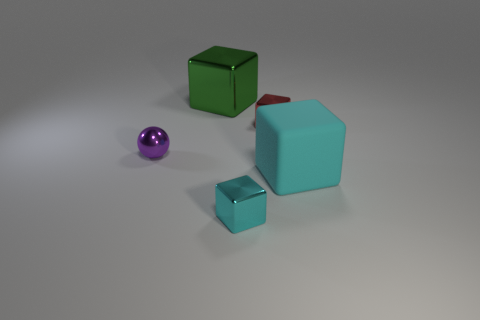Subtract all gray blocks. Subtract all yellow cylinders. How many blocks are left? 4 Add 5 cubes. How many objects exist? 10 Subtract all spheres. How many objects are left? 4 Add 2 tiny red blocks. How many tiny red blocks are left? 3 Add 3 purple balls. How many purple balls exist? 4 Subtract 0 brown spheres. How many objects are left? 5 Subtract all small gray matte spheres. Subtract all tiny cyan objects. How many objects are left? 4 